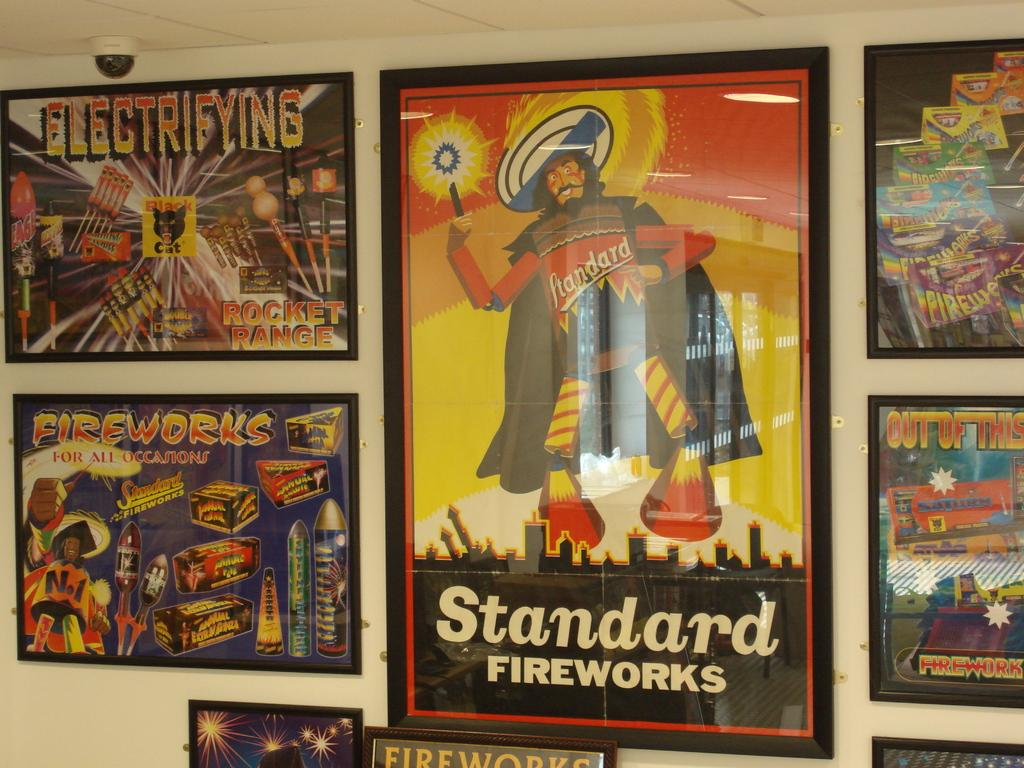What is hanging on the wall in the image? There are photo frames on the wall in the image. What is featured within the photo frames? The photo frames contain text and images. What type of spark can be seen coming from the office in the image? There is no office present in the image, and therefore no spark can be observed. What type of pear is visible in the image? There is no pear present in the image. 